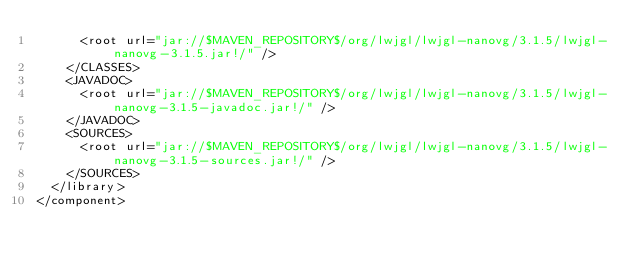<code> <loc_0><loc_0><loc_500><loc_500><_XML_>      <root url="jar://$MAVEN_REPOSITORY$/org/lwjgl/lwjgl-nanovg/3.1.5/lwjgl-nanovg-3.1.5.jar!/" />
    </CLASSES>
    <JAVADOC>
      <root url="jar://$MAVEN_REPOSITORY$/org/lwjgl/lwjgl-nanovg/3.1.5/lwjgl-nanovg-3.1.5-javadoc.jar!/" />
    </JAVADOC>
    <SOURCES>
      <root url="jar://$MAVEN_REPOSITORY$/org/lwjgl/lwjgl-nanovg/3.1.5/lwjgl-nanovg-3.1.5-sources.jar!/" />
    </SOURCES>
  </library>
</component></code> 